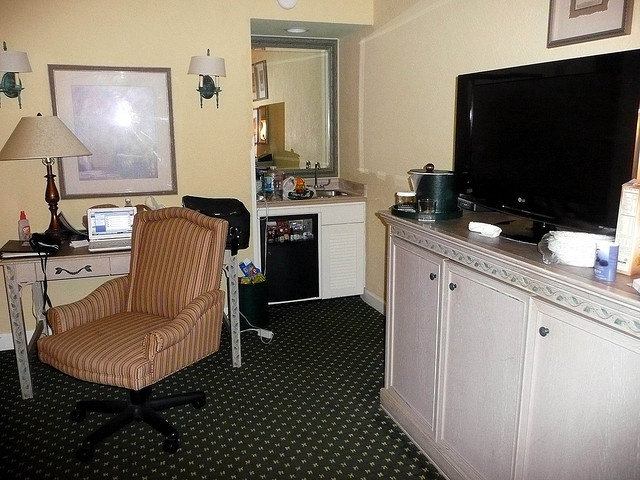Describe the objects in this image and their specific colors. I can see tv in olive, black, gray, ivory, and darkgray tones, chair in olive, gray, brown, black, and maroon tones, suitcase in olive, black, gray, and darkgray tones, laptop in olive, lightgray, darkgray, and gray tones, and sink in olive, gray, and darkgray tones in this image. 